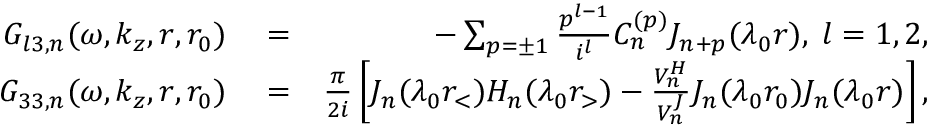Convert formula to latex. <formula><loc_0><loc_0><loc_500><loc_500>\begin{array} { r l r } { G _ { l 3 , n } ( \omega , k _ { z } , r , r _ { 0 } ) } & = } & { - \sum _ { p = \pm 1 } \frac { p ^ { l - 1 } } { i ^ { l } } C _ { n } ^ { ( p ) } J _ { n + p } ( \lambda _ { 0 } r ) , \, l = 1 , 2 , } \\ { G _ { 3 3 , n } ( \omega , k _ { z } , r , r _ { 0 } ) } & = } & { \frac { \pi } { 2 i } \left [ J _ { n } ( \lambda _ { 0 } r _ { < } ) H _ { n } ( \lambda _ { 0 } r _ { > } ) - \frac { V _ { n } ^ { H } } { V _ { n } ^ { J } } J _ { n } ( \lambda _ { 0 } r _ { 0 } ) J _ { n } ( \lambda _ { 0 } r ) \right ] , } \end{array}</formula> 